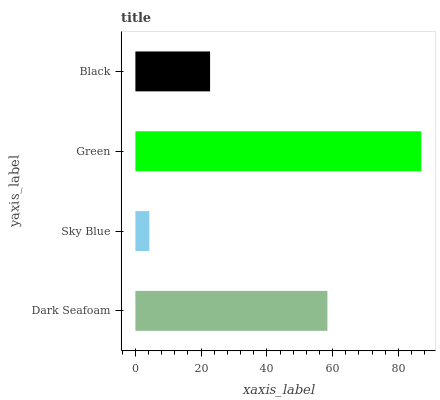Is Sky Blue the minimum?
Answer yes or no. Yes. Is Green the maximum?
Answer yes or no. Yes. Is Green the minimum?
Answer yes or no. No. Is Sky Blue the maximum?
Answer yes or no. No. Is Green greater than Sky Blue?
Answer yes or no. Yes. Is Sky Blue less than Green?
Answer yes or no. Yes. Is Sky Blue greater than Green?
Answer yes or no. No. Is Green less than Sky Blue?
Answer yes or no. No. Is Dark Seafoam the high median?
Answer yes or no. Yes. Is Black the low median?
Answer yes or no. Yes. Is Sky Blue the high median?
Answer yes or no. No. Is Green the low median?
Answer yes or no. No. 